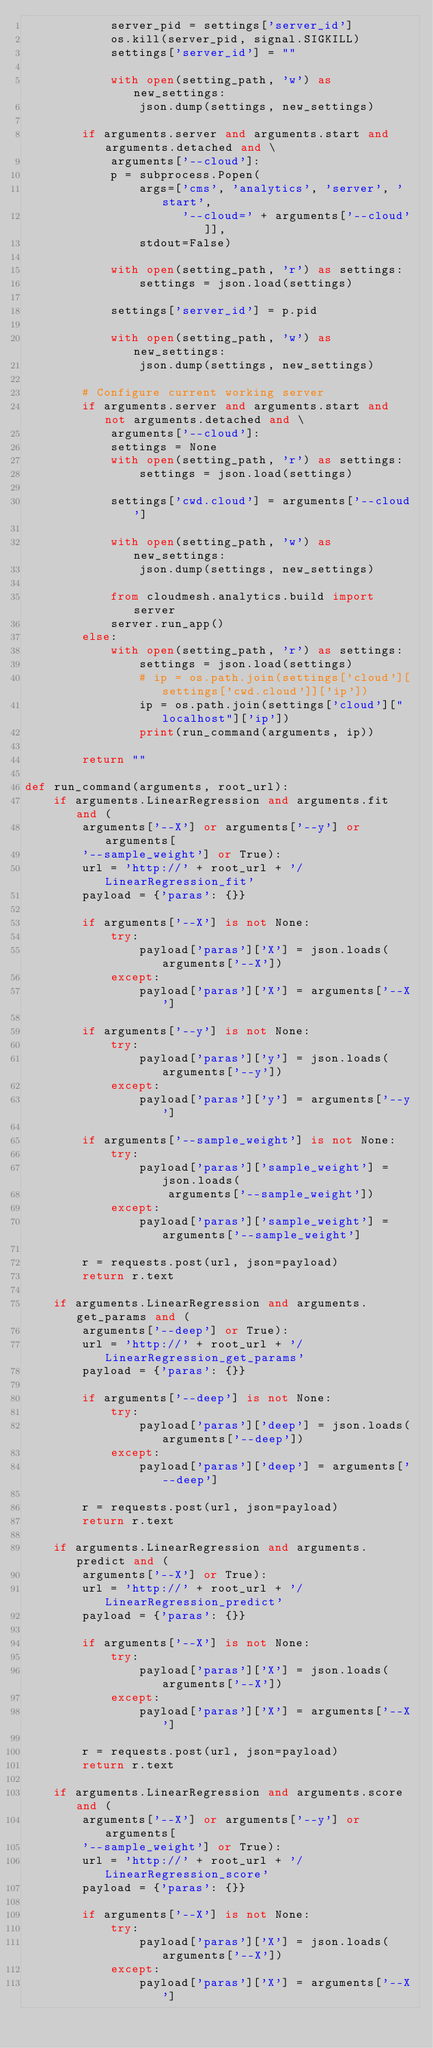<code> <loc_0><loc_0><loc_500><loc_500><_Python_>            server_pid = settings['server_id']
            os.kill(server_pid, signal.SIGKILL)
            settings['server_id'] = ""

            with open(setting_path, 'w') as new_settings:
                json.dump(settings, new_settings)

        if arguments.server and arguments.start and arguments.detached and \
            arguments['--cloud']:
            p = subprocess.Popen(
                args=['cms', 'analytics', 'server', 'start',
                      '--cloud=' + arguments['--cloud']],
                stdout=False)

            with open(setting_path, 'r') as settings:
                settings = json.load(settings)

            settings['server_id'] = p.pid

            with open(setting_path, 'w') as new_settings:
                json.dump(settings, new_settings)

        # Configure current working server
        if arguments.server and arguments.start and not arguments.detached and \
            arguments['--cloud']:
            settings = None
            with open(setting_path, 'r') as settings:
                settings = json.load(settings)

            settings['cwd.cloud'] = arguments['--cloud']

            with open(setting_path, 'w') as new_settings:
                json.dump(settings, new_settings)

            from cloudmesh.analytics.build import server
            server.run_app()
        else:
            with open(setting_path, 'r') as settings:
                settings = json.load(settings)
                # ip = os.path.join(settings['cloud'][settings['cwd.cloud']]['ip'])
                ip = os.path.join(settings['cloud']["localhost"]['ip'])
                print(run_command(arguments, ip))

        return ""

def run_command(arguments, root_url):
    if arguments.LinearRegression and arguments.fit and (
        arguments['--X'] or arguments['--y'] or arguments[
        '--sample_weight'] or True):
        url = 'http://' + root_url + '/LinearRegression_fit'
        payload = {'paras': {}}

        if arguments['--X'] is not None:
            try:
                payload['paras']['X'] = json.loads(arguments['--X'])
            except:
                payload['paras']['X'] = arguments['--X']

        if arguments['--y'] is not None:
            try:
                payload['paras']['y'] = json.loads(arguments['--y'])
            except:
                payload['paras']['y'] = arguments['--y']

        if arguments['--sample_weight'] is not None:
            try:
                payload['paras']['sample_weight'] = json.loads(
                    arguments['--sample_weight'])
            except:
                payload['paras']['sample_weight'] = arguments['--sample_weight']

        r = requests.post(url, json=payload)
        return r.text

    if arguments.LinearRegression and arguments.get_params and (
        arguments['--deep'] or True):
        url = 'http://' + root_url + '/LinearRegression_get_params'
        payload = {'paras': {}}

        if arguments['--deep'] is not None:
            try:
                payload['paras']['deep'] = json.loads(arguments['--deep'])
            except:
                payload['paras']['deep'] = arguments['--deep']

        r = requests.post(url, json=payload)
        return r.text

    if arguments.LinearRegression and arguments.predict and (
        arguments['--X'] or True):
        url = 'http://' + root_url + '/LinearRegression_predict'
        payload = {'paras': {}}

        if arguments['--X'] is not None:
            try:
                payload['paras']['X'] = json.loads(arguments['--X'])
            except:
                payload['paras']['X'] = arguments['--X']

        r = requests.post(url, json=payload)
        return r.text

    if arguments.LinearRegression and arguments.score and (
        arguments['--X'] or arguments['--y'] or arguments[
        '--sample_weight'] or True):
        url = 'http://' + root_url + '/LinearRegression_score'
        payload = {'paras': {}}

        if arguments['--X'] is not None:
            try:
                payload['paras']['X'] = json.loads(arguments['--X'])
            except:
                payload['paras']['X'] = arguments['--X']
</code> 